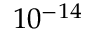<formula> <loc_0><loc_0><loc_500><loc_500>1 0 ^ { - 1 4 }</formula> 